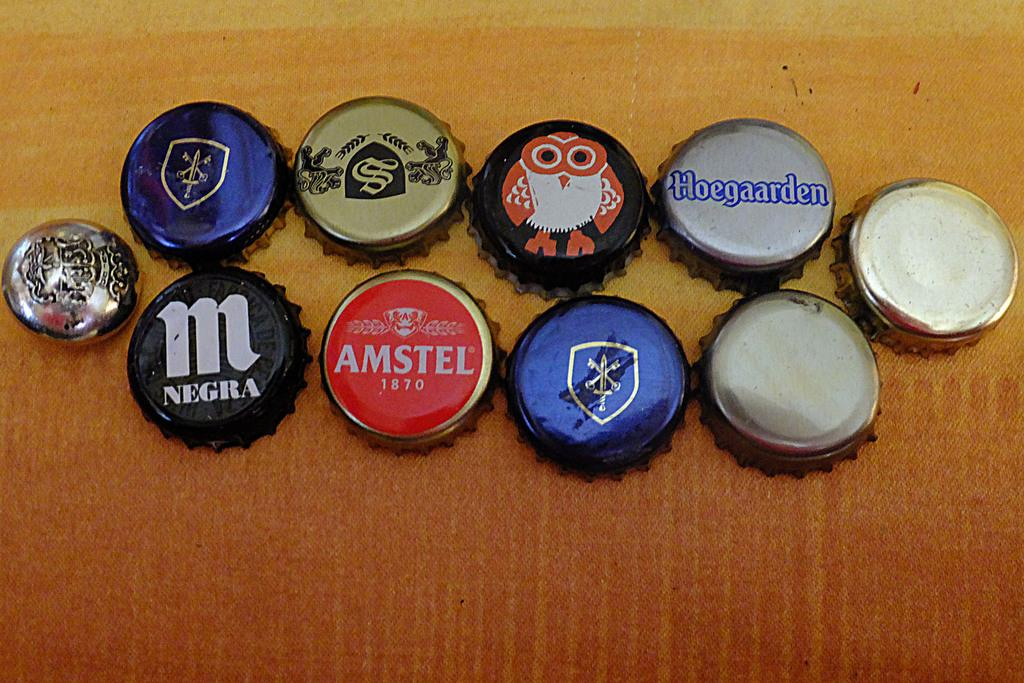What objects are visible in the image? There are metal lids of bottles in the image. Where are the metal lids located? The metal lids are placed on a surface. What can be found on the metal lids? There is text and pictures on the metal lids. How many pets can be seen playing with the snails in the image? There are no pets or snails present in the image; it only features metal lids of bottles. 